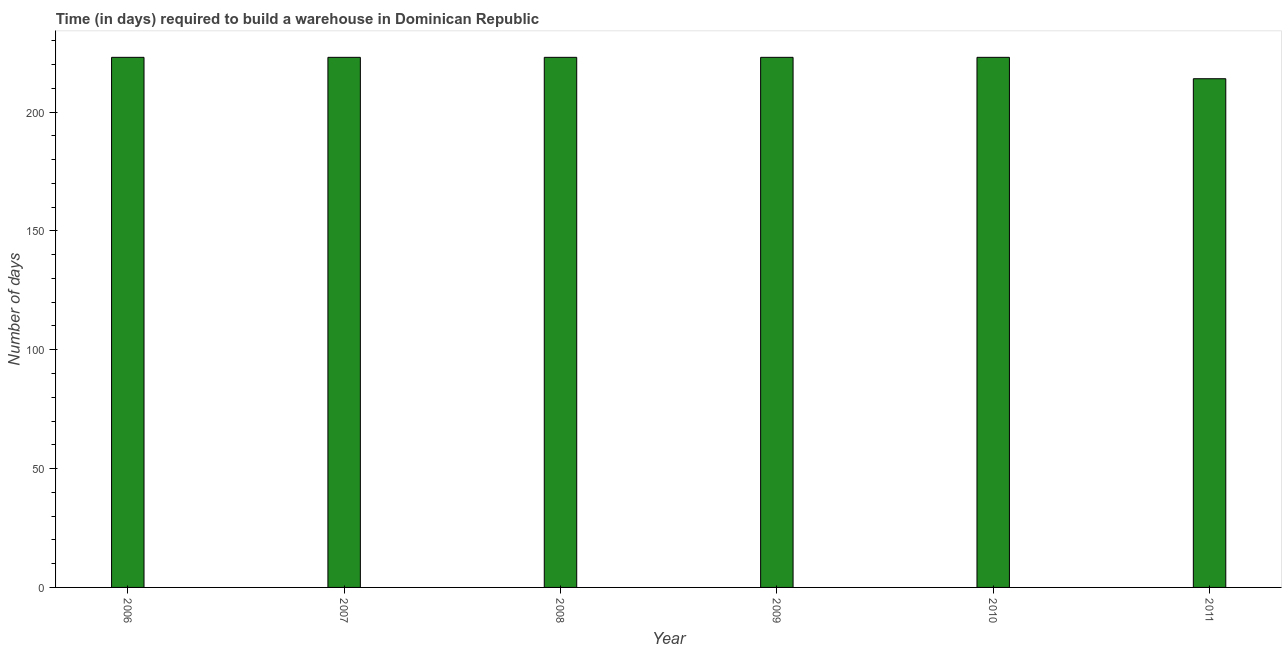What is the title of the graph?
Provide a short and direct response. Time (in days) required to build a warehouse in Dominican Republic. What is the label or title of the X-axis?
Offer a very short reply. Year. What is the label or title of the Y-axis?
Provide a succinct answer. Number of days. What is the time required to build a warehouse in 2007?
Your answer should be compact. 223. Across all years, what is the maximum time required to build a warehouse?
Offer a terse response. 223. Across all years, what is the minimum time required to build a warehouse?
Provide a succinct answer. 214. In which year was the time required to build a warehouse maximum?
Offer a very short reply. 2006. In which year was the time required to build a warehouse minimum?
Provide a short and direct response. 2011. What is the sum of the time required to build a warehouse?
Offer a very short reply. 1329. What is the average time required to build a warehouse per year?
Your answer should be very brief. 221. What is the median time required to build a warehouse?
Give a very brief answer. 223. Do a majority of the years between 2009 and 2007 (inclusive) have time required to build a warehouse greater than 100 days?
Provide a succinct answer. Yes. How many years are there in the graph?
Ensure brevity in your answer.  6. Are the values on the major ticks of Y-axis written in scientific E-notation?
Ensure brevity in your answer.  No. What is the Number of days of 2006?
Give a very brief answer. 223. What is the Number of days in 2007?
Provide a succinct answer. 223. What is the Number of days in 2008?
Provide a succinct answer. 223. What is the Number of days of 2009?
Provide a short and direct response. 223. What is the Number of days of 2010?
Your response must be concise. 223. What is the Number of days of 2011?
Your answer should be compact. 214. What is the difference between the Number of days in 2006 and 2007?
Make the answer very short. 0. What is the difference between the Number of days in 2006 and 2010?
Ensure brevity in your answer.  0. What is the difference between the Number of days in 2006 and 2011?
Ensure brevity in your answer.  9. What is the difference between the Number of days in 2007 and 2009?
Give a very brief answer. 0. What is the difference between the Number of days in 2008 and 2011?
Provide a short and direct response. 9. What is the difference between the Number of days in 2009 and 2010?
Your answer should be compact. 0. What is the difference between the Number of days in 2010 and 2011?
Offer a terse response. 9. What is the ratio of the Number of days in 2006 to that in 2010?
Offer a very short reply. 1. What is the ratio of the Number of days in 2006 to that in 2011?
Offer a terse response. 1.04. What is the ratio of the Number of days in 2007 to that in 2009?
Give a very brief answer. 1. What is the ratio of the Number of days in 2007 to that in 2011?
Your response must be concise. 1.04. What is the ratio of the Number of days in 2008 to that in 2009?
Provide a succinct answer. 1. What is the ratio of the Number of days in 2008 to that in 2011?
Make the answer very short. 1.04. What is the ratio of the Number of days in 2009 to that in 2010?
Give a very brief answer. 1. What is the ratio of the Number of days in 2009 to that in 2011?
Your answer should be very brief. 1.04. What is the ratio of the Number of days in 2010 to that in 2011?
Ensure brevity in your answer.  1.04. 